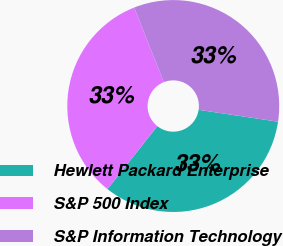<chart> <loc_0><loc_0><loc_500><loc_500><pie_chart><fcel>Hewlett Packard Enterprise<fcel>S&P 500 Index<fcel>S&P Information Technology<nl><fcel>33.3%<fcel>33.33%<fcel>33.37%<nl></chart> 